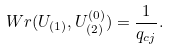Convert formula to latex. <formula><loc_0><loc_0><loc_500><loc_500>W r ( U _ { ( 1 ) } , U _ { ( 2 ) } ^ { ( 0 ) } ) = \frac { 1 } { q _ { c j } } .</formula> 